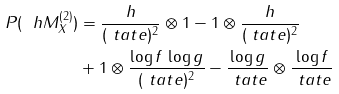Convert formula to latex. <formula><loc_0><loc_0><loc_500><loc_500>P ( \ h M ^ { ( 2 ) } _ { X } ) & = \frac { h } { ( \ t a t e ) ^ { 2 } } \otimes 1 - 1 \otimes \frac { h } { ( \ t a t e ) ^ { 2 } } \\ & + 1 \otimes \frac { \log f \, \log g } { ( \ t a t e ) ^ { 2 } } - \frac { \log g } { \ t a t e } \otimes \frac { \log f } { \ t a t e }</formula> 